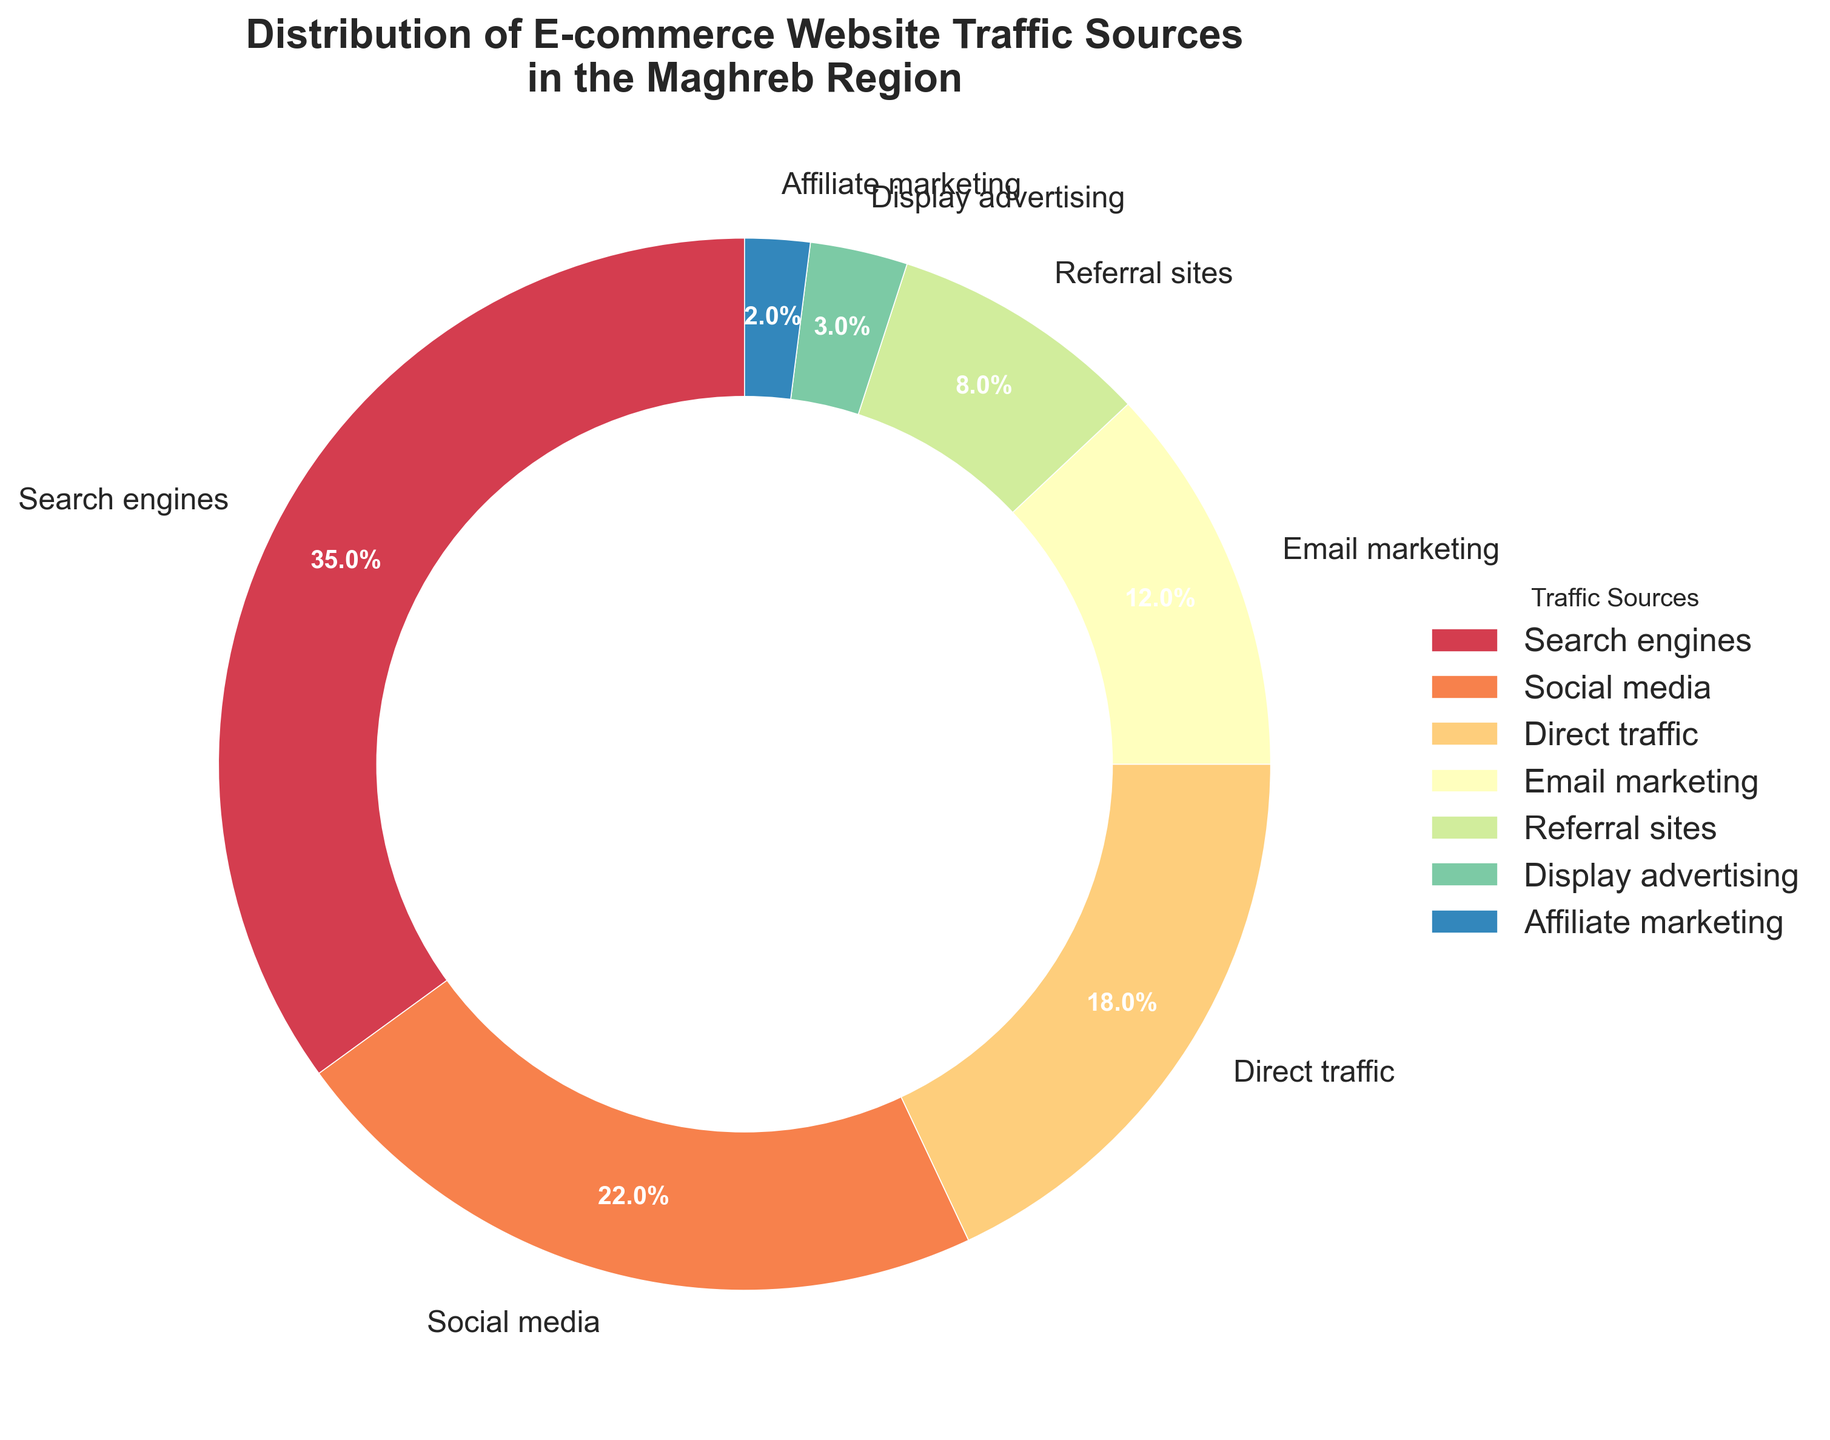Which traffic source has the largest share? By looking at the pie chart, the traffic source with the largest share can be identified by the size of its segment. The largest segment is labeled "Search engines" with a percentage of 35.0%.
Answer: Search engines How much larger is the percentage of traffic from search engines compared to social media? First, identify the percentages for search engines (35%) and social media (22%). Subtract the smaller percentage from the larger one: 35% - 22% = 13%.
Answer: 13% Which sources combined account for exactly 30% of the traffic? Look at the pie chart labels and find combinations of sources whose sums equal 30%. "Referral sites" (8%) and "Email marketing" (12%) together with "Affiliate marketing" (2%) and "Display advertising" (3%) also sum to 30%. (8% + 12% + 2% + 3% = 25%; so not them; try pairing) Social media (22%) and Display advertising (3%); 22+3=25 not. Email marketing (12%) + 18% (Direct traffic) = 30.
Answer: Social media + Direct traffic What is the total percentage of traffic driven by referral sites and display advertising combined? Identify the percentages for referral sites (8%) and display advertising (3%). Sum these percentages: 8% + 3% = 11%.
Answer: 11% Which traffic source segment is closest in size to affiliate marketing? Find the percentage for affiliate marketing (2%). The segment closest in size to it is "Display advertising," which has a percentage of 3%.
Answer: Display advertising Is the percentage of traffic from email marketing greater than that from direct traffic? Look at the pie chart and compare the percentages: email marketing (12%) and direct traffic (18%). Since 12% < 18%, email marketing is not greater than direct traffic.
Answer: No What fraction of the total traffic comes from email marketing? The pie chart shows email marketing at 12%. Convert the percentage to a fraction: 12% = 12/100 = 3/25.
Answer: 3/25 How do the percentages of direct traffic and social media compare to one another? Identify the percentages: direct traffic (18%) and social media (22%). Compare these values: 18% < 22%, so social media has a higher percentage than direct traffic.
Answer: Social media has a higher percentage Which traffic sources combined exceed 50%? Identify sources and sum their percentages until the total exceeds 50%. Start with the largest sources: Search engines (35%) + Social media (22%) = 57%, which exceeds 50%.
Answer: Search engines and Social media What is the difference in percentage between the smallest and largest traffic sources? Identify the smallest source (affiliate marketing, 2%) and the largest source (search engines, 35%). Calculate the difference: 35% - 2% = 33%.
Answer: 33% 